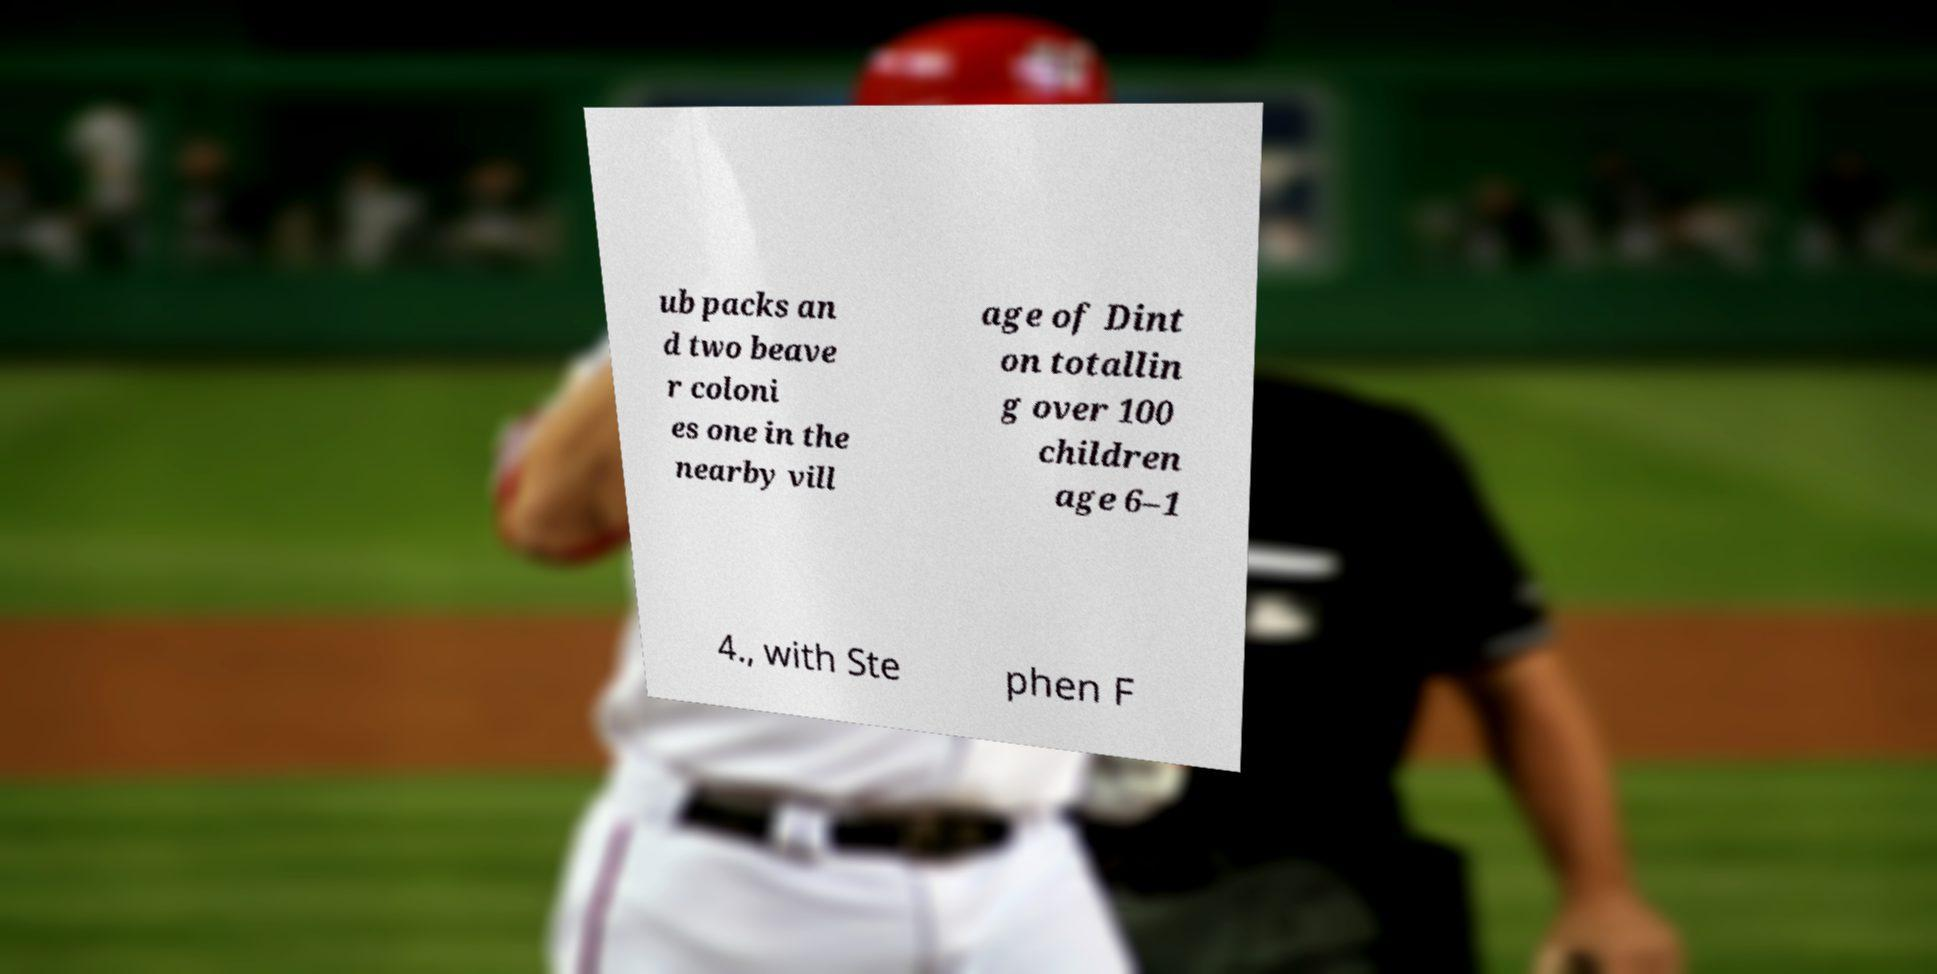For documentation purposes, I need the text within this image transcribed. Could you provide that? ub packs an d two beave r coloni es one in the nearby vill age of Dint on totallin g over 100 children age 6–1 4., with Ste phen F 